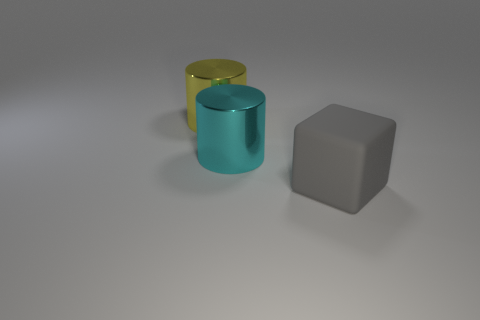How do the objects compare in terms of their spatial arrangement? The objects are evenly spaced apart on a flat surface, creating a sense of balance within the composition. The cylindrical objects and the cube are arranged in a staggered fashion, which may provide a visually pleasing or purposeful layout. 